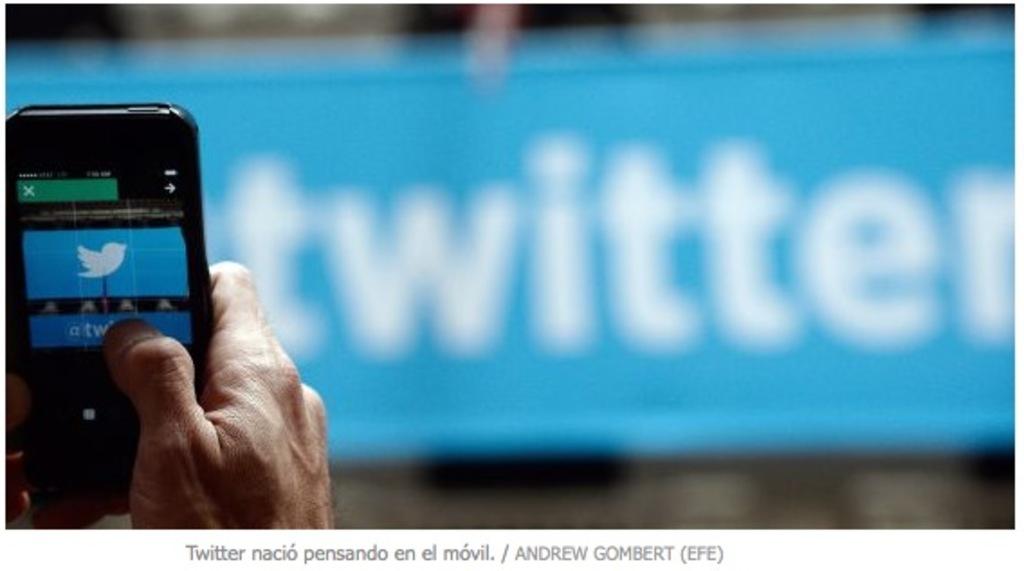What website company is in the background?
Provide a succinct answer. Twitter. The company is twitter?
Your answer should be compact. Yes. 